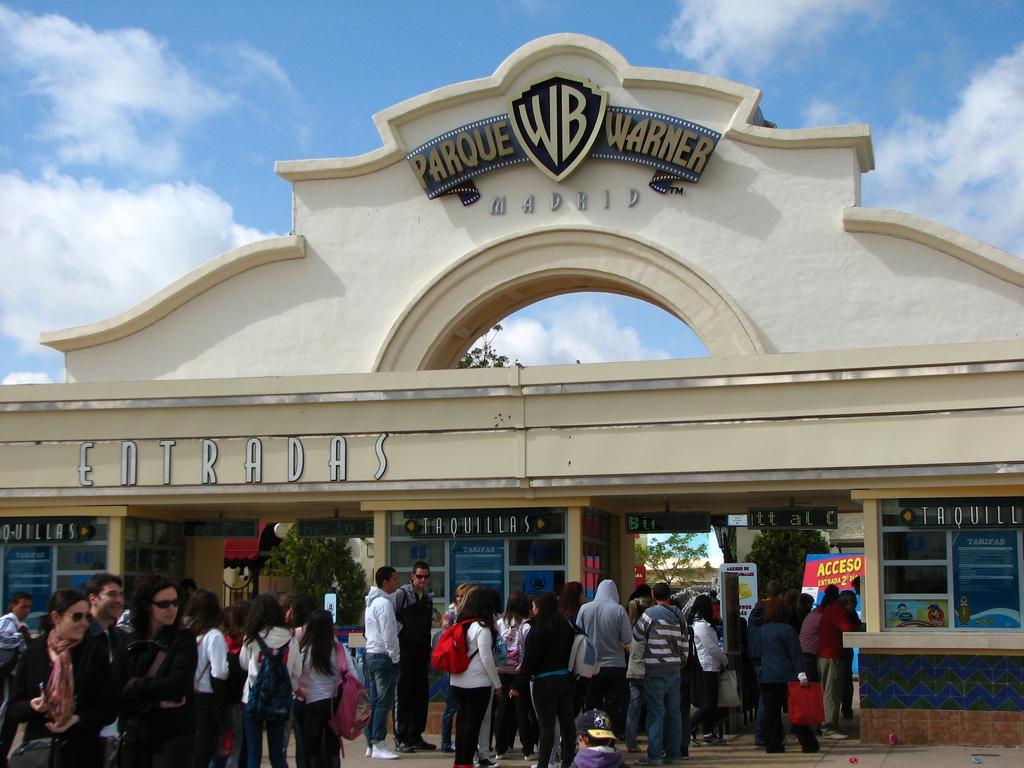How would you summarize this image in a sentence or two? In this image I can see the group of people are standing and few are holding bags. In front I can see few stores, windows, trees and the arch. The sky is in blue and white color. 